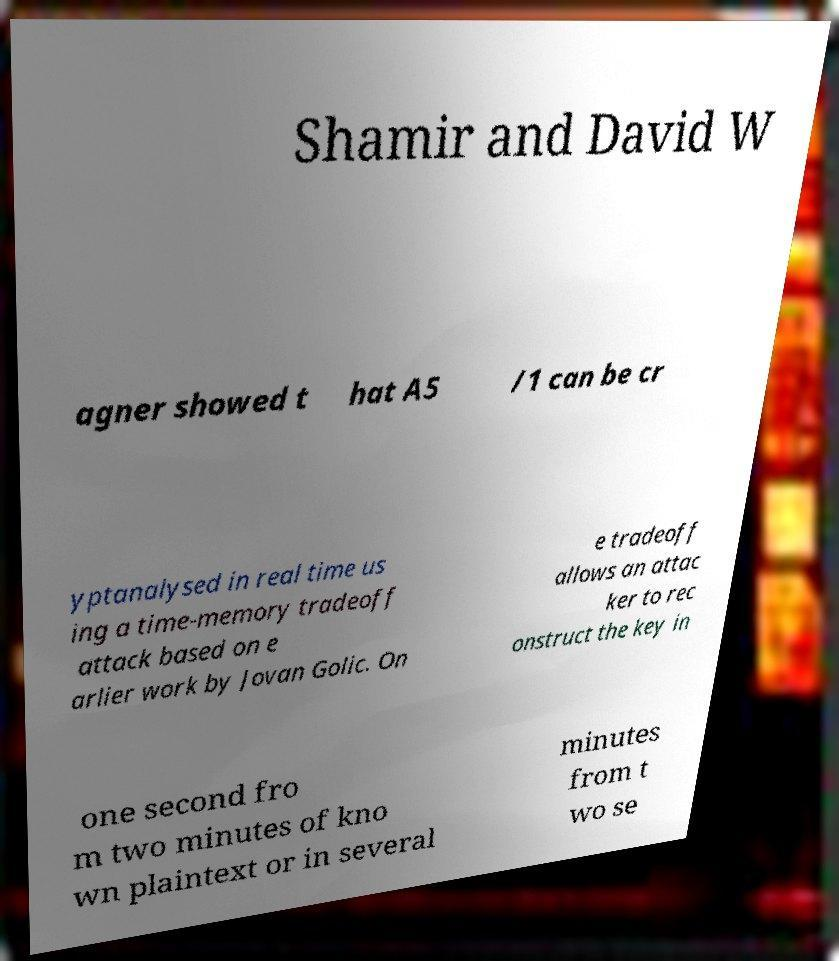Please read and relay the text visible in this image. What does it say? Shamir and David W agner showed t hat A5 /1 can be cr yptanalysed in real time us ing a time-memory tradeoff attack based on e arlier work by Jovan Golic. On e tradeoff allows an attac ker to rec onstruct the key in one second fro m two minutes of kno wn plaintext or in several minutes from t wo se 